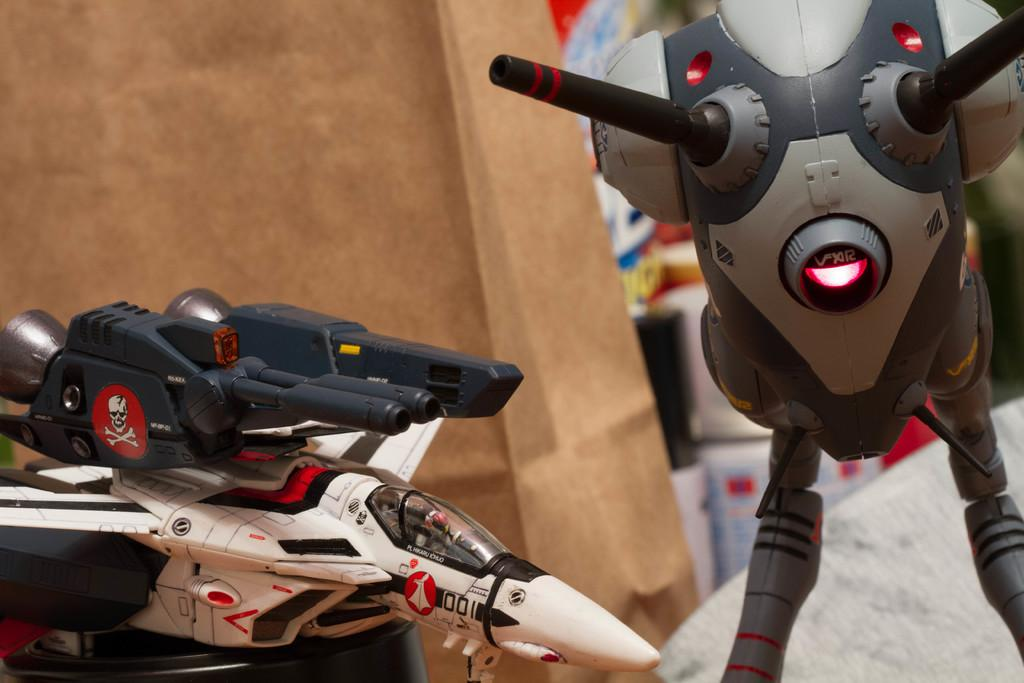What type of toys are present in the image? There are electric toys in the image. Where are the electric toys located in relation to other objects? The electric toys are in front of a paper bag. What type of health benefits can be gained from playing with the electric toys in the image? The image does not provide information about any health benefits associated with the electric toys. 